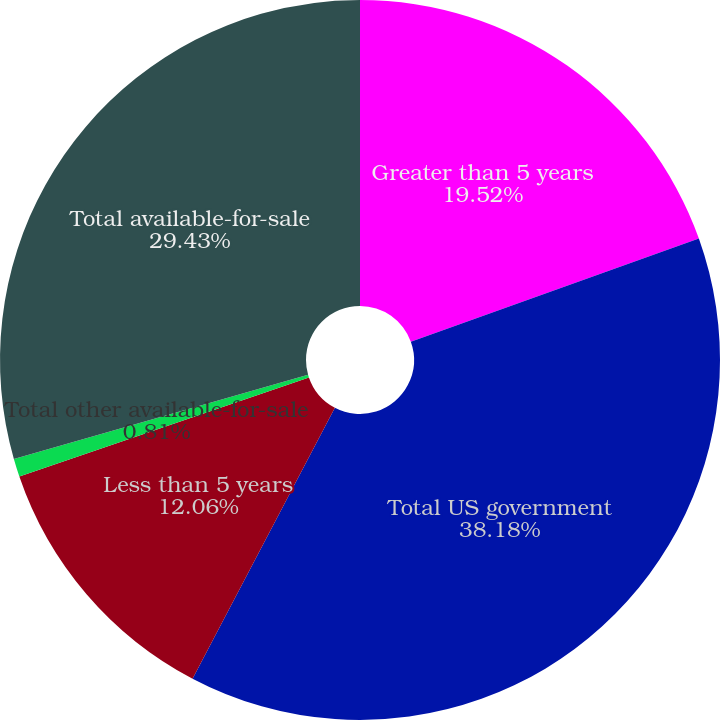<chart> <loc_0><loc_0><loc_500><loc_500><pie_chart><fcel>Greater than 5 years<fcel>Total US government<fcel>Less than 5 years<fcel>Total other available-for-sale<fcel>Total available-for-sale<nl><fcel>19.52%<fcel>38.18%<fcel>12.06%<fcel>0.81%<fcel>29.43%<nl></chart> 